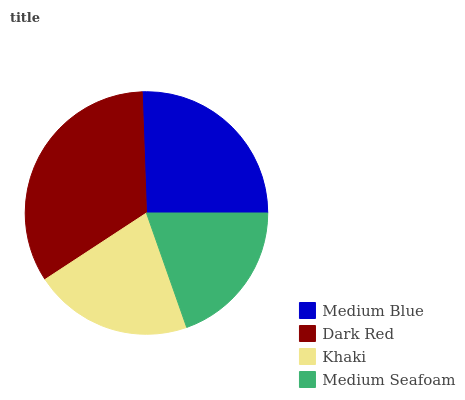Is Medium Seafoam the minimum?
Answer yes or no. Yes. Is Dark Red the maximum?
Answer yes or no. Yes. Is Khaki the minimum?
Answer yes or no. No. Is Khaki the maximum?
Answer yes or no. No. Is Dark Red greater than Khaki?
Answer yes or no. Yes. Is Khaki less than Dark Red?
Answer yes or no. Yes. Is Khaki greater than Dark Red?
Answer yes or no. No. Is Dark Red less than Khaki?
Answer yes or no. No. Is Medium Blue the high median?
Answer yes or no. Yes. Is Khaki the low median?
Answer yes or no. Yes. Is Khaki the high median?
Answer yes or no. No. Is Medium Seafoam the low median?
Answer yes or no. No. 